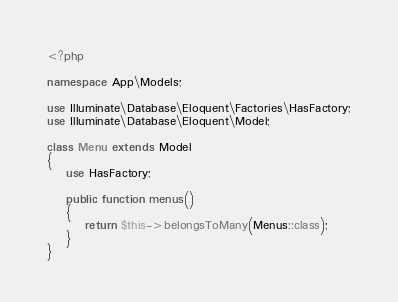Convert code to text. <code><loc_0><loc_0><loc_500><loc_500><_PHP_><?php

namespace App\Models;

use Illuminate\Database\Eloquent\Factories\HasFactory;
use Illuminate\Database\Eloquent\Model;

class Menu extends Model
{
    use HasFactory;

    public function menus()
    {
        return $this->belongsToMany(Menus::class);
    }
}
</code> 